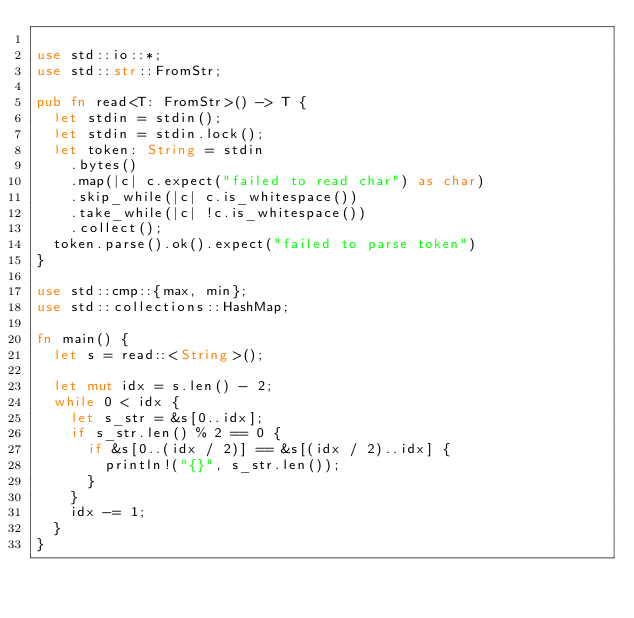<code> <loc_0><loc_0><loc_500><loc_500><_Rust_>
use std::io::*;
use std::str::FromStr;

pub fn read<T: FromStr>() -> T {
  let stdin = stdin();
  let stdin = stdin.lock();
  let token: String = stdin
    .bytes()
    .map(|c| c.expect("failed to read char") as char)
    .skip_while(|c| c.is_whitespace())
    .take_while(|c| !c.is_whitespace())
    .collect();
  token.parse().ok().expect("failed to parse token")
}

use std::cmp::{max, min};
use std::collections::HashMap;

fn main() {
  let s = read::<String>();

  let mut idx = s.len() - 2;
  while 0 < idx {
    let s_str = &s[0..idx];
    if s_str.len() % 2 == 0 {
      if &s[0..(idx / 2)] == &s[(idx / 2)..idx] {
        println!("{}", s_str.len());
      }
    }
    idx -= 1;
  }
}
</code> 